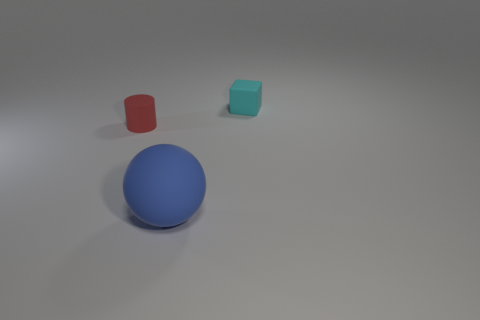How would you describe the texture of the surface on which the objects are placed? The surface appears smooth and even, likely a kind of matte finish that minimally reflects the light, giving it a soft appearance. 